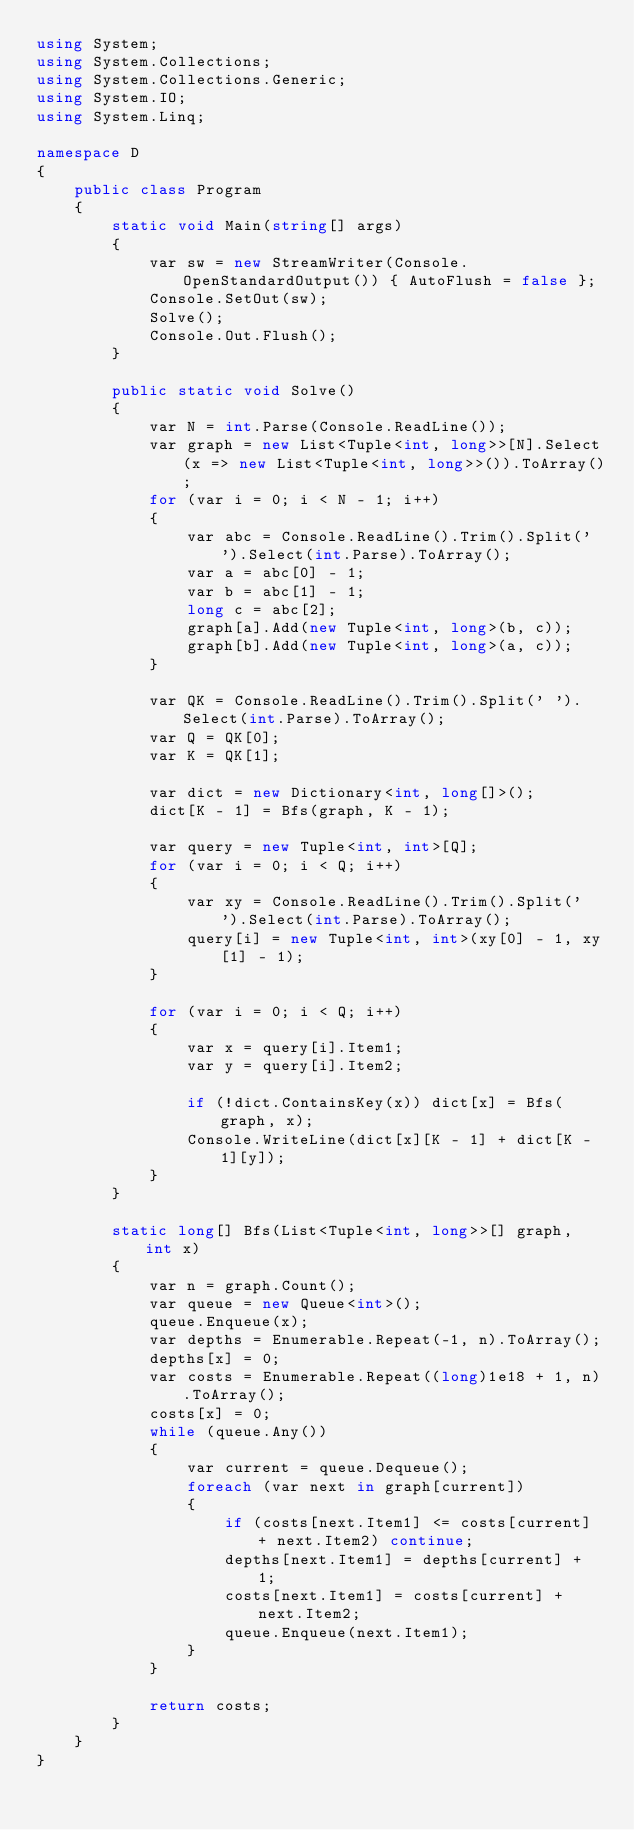Convert code to text. <code><loc_0><loc_0><loc_500><loc_500><_C#_>using System;
using System.Collections;
using System.Collections.Generic;
using System.IO;
using System.Linq;

namespace D
{
    public class Program
    {
        static void Main(string[] args)
        {
            var sw = new StreamWriter(Console.OpenStandardOutput()) { AutoFlush = false };
            Console.SetOut(sw);
            Solve();
            Console.Out.Flush();
        }

        public static void Solve()
        {
            var N = int.Parse(Console.ReadLine());
            var graph = new List<Tuple<int, long>>[N].Select(x => new List<Tuple<int, long>>()).ToArray();
            for (var i = 0; i < N - 1; i++)
            {
                var abc = Console.ReadLine().Trim().Split(' ').Select(int.Parse).ToArray();
                var a = abc[0] - 1;
                var b = abc[1] - 1;
                long c = abc[2];
                graph[a].Add(new Tuple<int, long>(b, c));
                graph[b].Add(new Tuple<int, long>(a, c));
            }

            var QK = Console.ReadLine().Trim().Split(' ').Select(int.Parse).ToArray();
            var Q = QK[0];
            var K = QK[1];

            var dict = new Dictionary<int, long[]>();
            dict[K - 1] = Bfs(graph, K - 1);

            var query = new Tuple<int, int>[Q];
            for (var i = 0; i < Q; i++)
            {
                var xy = Console.ReadLine().Trim().Split(' ').Select(int.Parse).ToArray();
                query[i] = new Tuple<int, int>(xy[0] - 1, xy[1] - 1);
            }

            for (var i = 0; i < Q; i++)
            {
                var x = query[i].Item1;
                var y = query[i].Item2;

                if (!dict.ContainsKey(x)) dict[x] = Bfs(graph, x);
                Console.WriteLine(dict[x][K - 1] + dict[K - 1][y]);
            }
        }

        static long[] Bfs(List<Tuple<int, long>>[] graph, int x)
        {
            var n = graph.Count();
            var queue = new Queue<int>();
            queue.Enqueue(x);
            var depths = Enumerable.Repeat(-1, n).ToArray();
            depths[x] = 0;
            var costs = Enumerable.Repeat((long)1e18 + 1, n).ToArray();
            costs[x] = 0;
            while (queue.Any())
            {
                var current = queue.Dequeue();
                foreach (var next in graph[current])
                {
                    if (costs[next.Item1] <= costs[current] + next.Item2) continue;
                    depths[next.Item1] = depths[current] + 1;
                    costs[next.Item1] = costs[current] + next.Item2;
                    queue.Enqueue(next.Item1);
                }
            }

            return costs;
        }
    }
}
</code> 